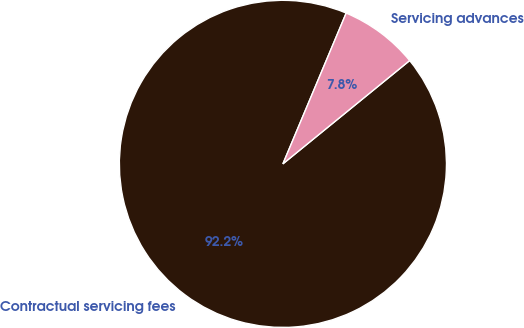<chart> <loc_0><loc_0><loc_500><loc_500><pie_chart><fcel>Contractual servicing fees<fcel>Servicing advances<nl><fcel>92.21%<fcel>7.79%<nl></chart> 